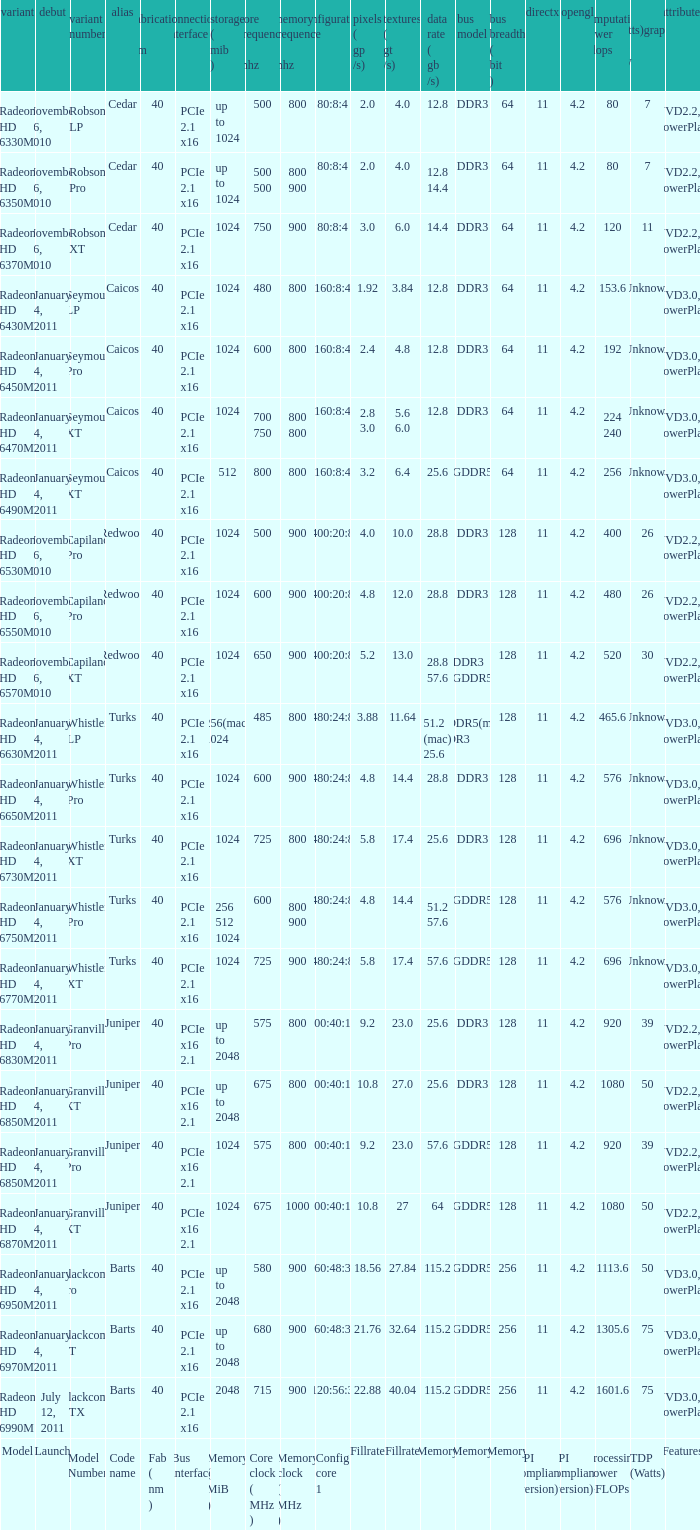What is every bus type for the texture of fillrate? Memory. 